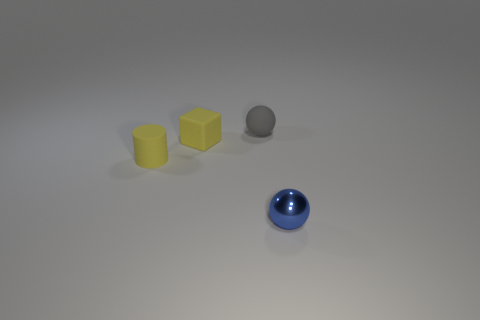Subtract all gray balls. How many balls are left? 1 Add 3 big brown matte cubes. How many objects exist? 7 Subtract all blocks. How many objects are left? 3 Subtract all red cylinders. Subtract all gray blocks. How many cylinders are left? 1 Subtract all yellow balls. How many purple cylinders are left? 0 Subtract all yellow rubber cylinders. Subtract all small gray rubber balls. How many objects are left? 2 Add 4 small blue balls. How many small blue balls are left? 5 Add 2 large cyan metallic objects. How many large cyan metallic objects exist? 2 Subtract 1 yellow cubes. How many objects are left? 3 